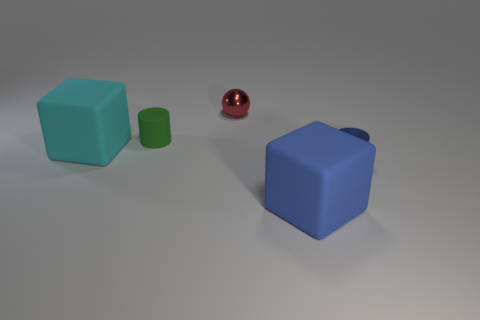What number of objects are small yellow rubber spheres or metal cylinders that are right of the tiny red metal thing?
Keep it short and to the point. 1. What is the material of the large object that is behind the large rubber object that is in front of the large cube that is left of the small rubber thing?
Provide a short and direct response. Rubber. Is there anything else that is made of the same material as the red thing?
Ensure brevity in your answer.  Yes. There is a big cube that is on the right side of the small green object; is it the same color as the sphere?
Ensure brevity in your answer.  No. How many blue things are either small matte cylinders or shiny objects?
Provide a succinct answer. 1. How many other things are the same shape as the red metallic object?
Your response must be concise. 0. Is the small blue cylinder made of the same material as the small ball?
Ensure brevity in your answer.  Yes. What is the material of the object that is to the right of the small green object and behind the tiny metal cylinder?
Your response must be concise. Metal. The small metal thing on the left side of the large blue matte object is what color?
Offer a very short reply. Red. Is the number of green cylinders to the right of the metallic cylinder greater than the number of balls?
Make the answer very short. No. 